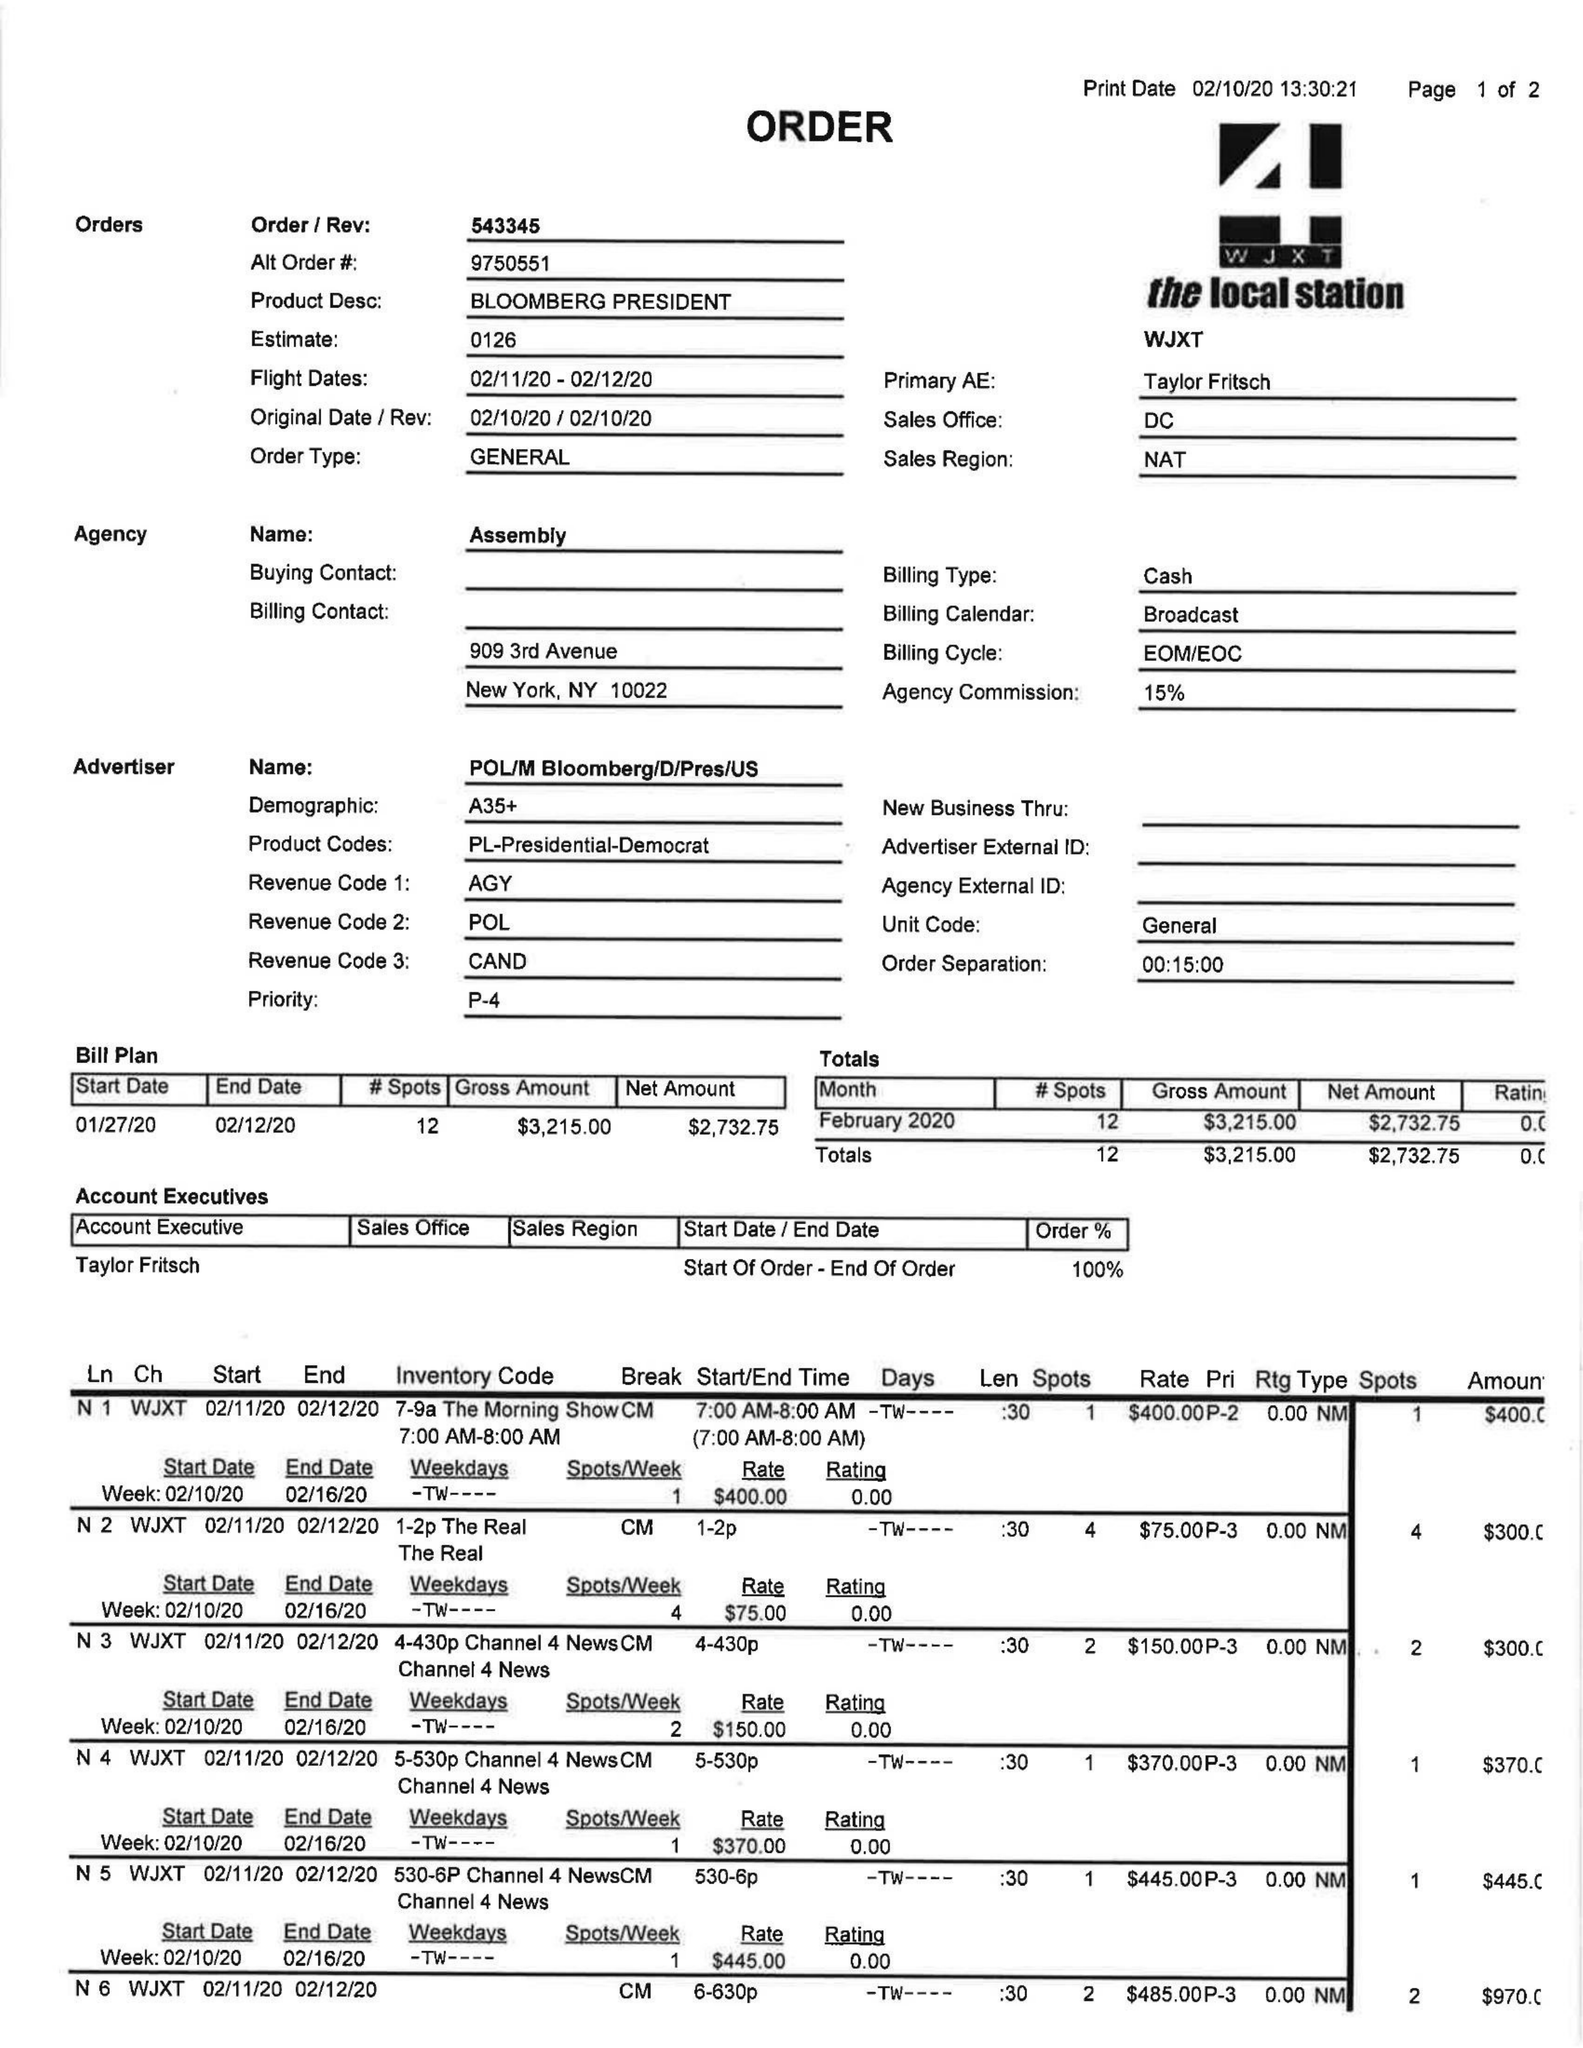What is the value for the flight_from?
Answer the question using a single word or phrase. 02/11/20 